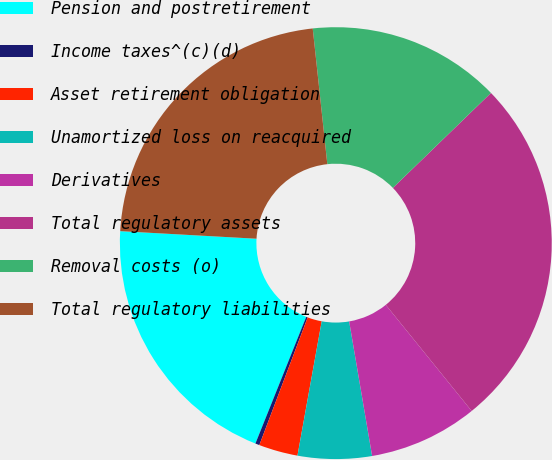Convert chart. <chart><loc_0><loc_0><loc_500><loc_500><pie_chart><fcel>Pension and postretirement<fcel>Income taxes^(c)(d)<fcel>Asset retirement obligation<fcel>Unamortized loss on reacquired<fcel>Derivatives<fcel>Total regulatory assets<fcel>Removal costs (o)<fcel>Total regulatory liabilities<nl><fcel>19.81%<fcel>0.31%<fcel>2.92%<fcel>5.53%<fcel>8.14%<fcel>26.41%<fcel>14.46%<fcel>22.41%<nl></chart> 